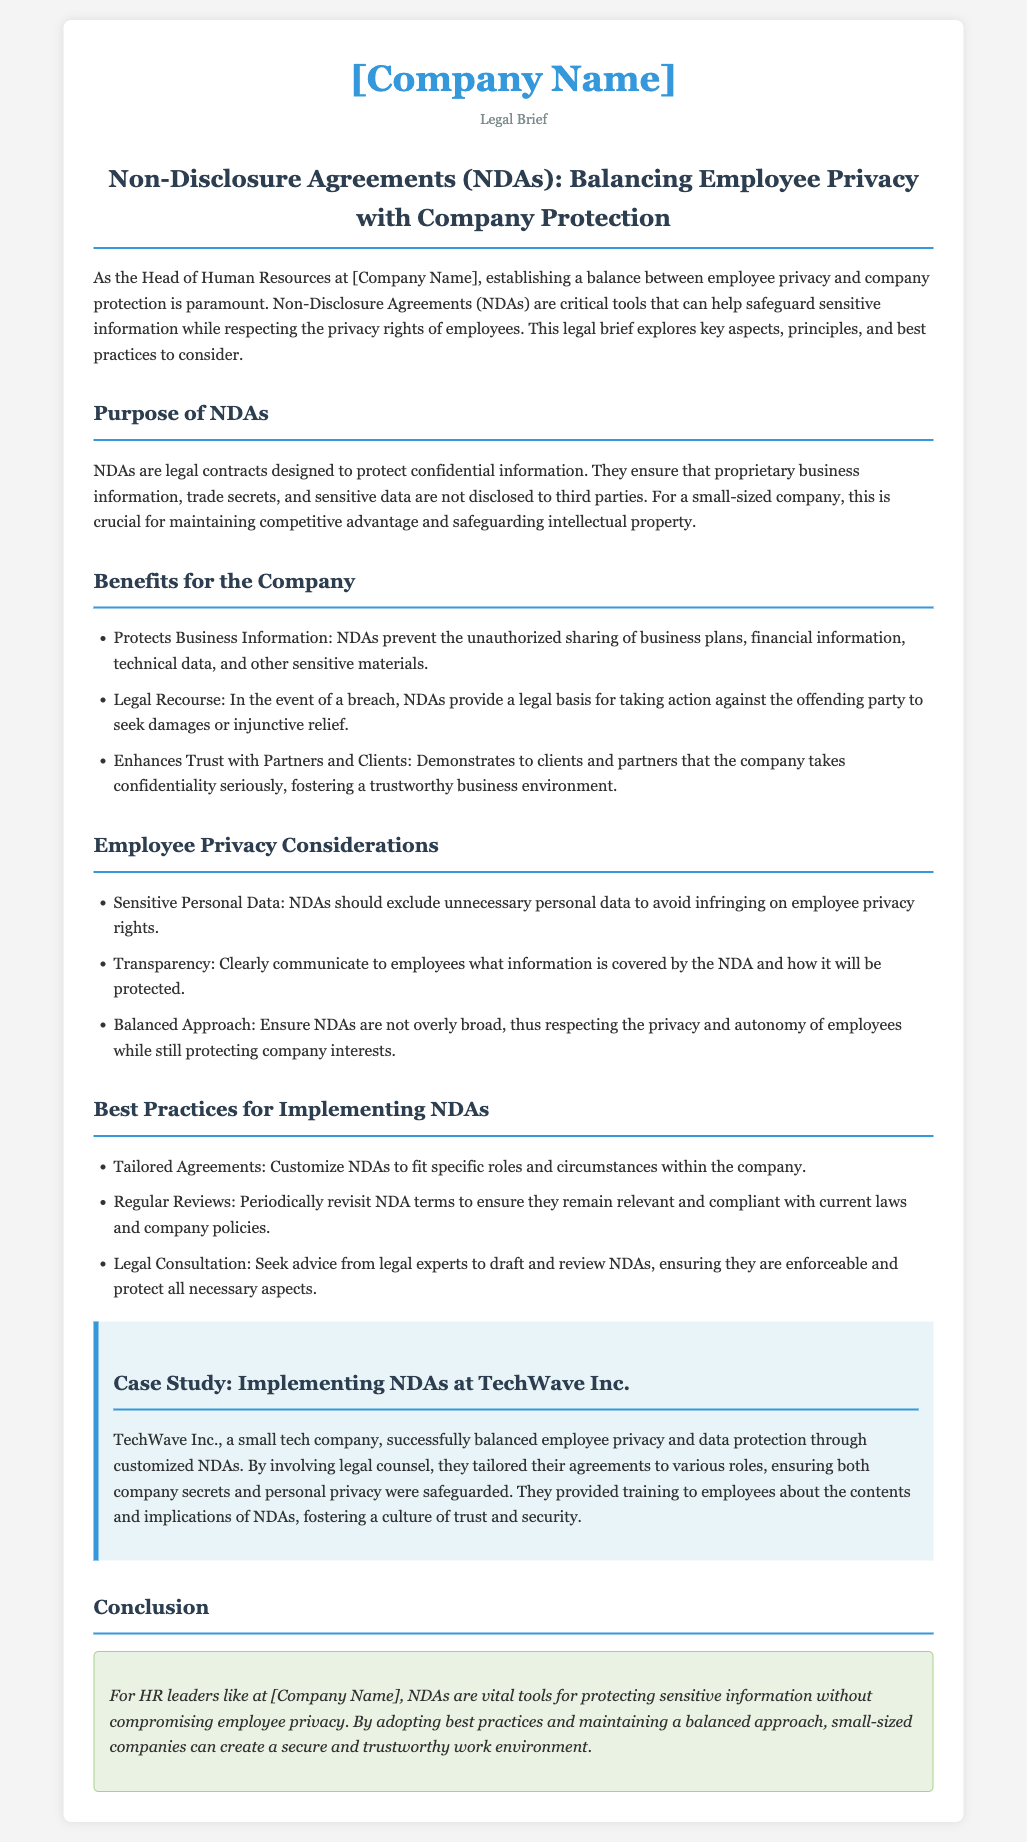What is the title of the document? The title of the document is presented as the main heading in the content.
Answer: Non-Disclosure Agreements (NDAs): Balancing Employee Privacy with Company Protection What are NDAs designed to protect? The purpose of NDAs is specified in the document under the relevant section.
Answer: Confidential information What is one benefit of NDAs for the company? The document lists several benefits of NDAs in a bulleted list.
Answer: Protects Business Information What should NDAs exclude to respect employee privacy? The document highlights specific considerations regarding employee privacy.
Answer: Unnecessary personal data What is a best practice for implementing NDAs? The document offers a list of best practices for fair NDA implementation.
Answer: Tailored Agreements How often should NDA terms be reviewed? The document recommends a frequency for reviewing NDA terms.
Answer: Periodically What does the case study highlight about TechWave Inc.? The case study presents an example relevant to the balancing of privacy and protection.
Answer: Customized NDAs Who should be consulted for drafting NDAs? The document suggests seeking particular expertise for NDA draft reviews.
Answer: Legal experts 